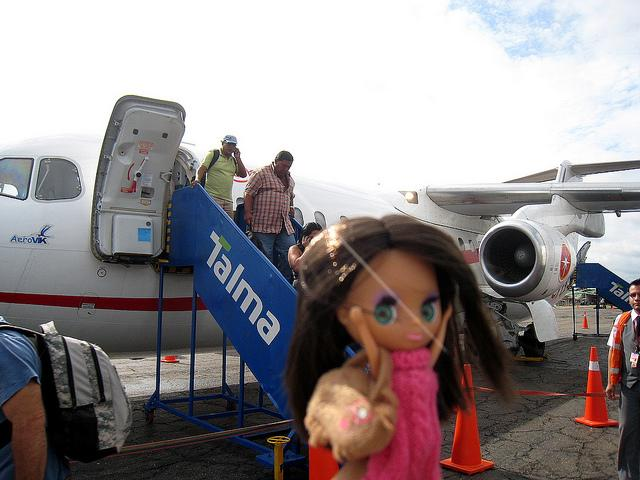What type of doll is in the front of the picture? Please explain your reasoning. bratz. The big eyes and face shape indicate which type of popular doll is being held. 